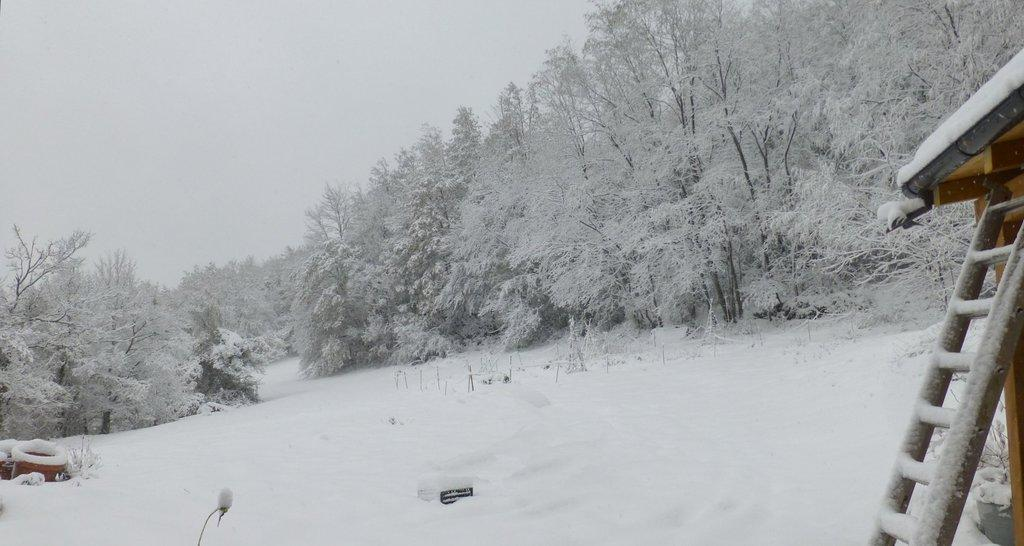What type of natural elements can be seen in the image? There are trees in the image. What man-made objects are present in the image? There are tubes and a stand in the image. What is the condition of the trees, tubes, and stand in the image? They are all covered in snow. What is visible at the bottom of the image? There is snow at the bottom of the image. Can you tell me how many carriages are flying through the air in the image? There are no carriages or flying objects present in the image. What type of creature might be biting the trees in the image? There are no creatures or biting activity depicted in the image. 